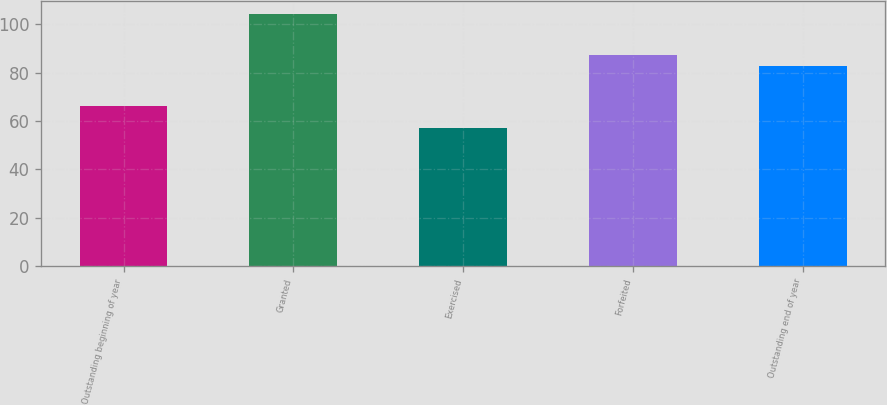Convert chart to OTSL. <chart><loc_0><loc_0><loc_500><loc_500><bar_chart><fcel>Outstanding beginning of year<fcel>Granted<fcel>Exercised<fcel>Forfeited<fcel>Outstanding end of year<nl><fcel>66.08<fcel>104.23<fcel>56.95<fcel>87.29<fcel>82.56<nl></chart> 